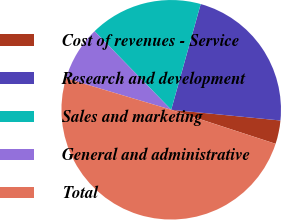<chart> <loc_0><loc_0><loc_500><loc_500><pie_chart><fcel>Cost of revenues - Service<fcel>Research and development<fcel>Sales and marketing<fcel>General and administrative<fcel>Total<nl><fcel>3.46%<fcel>22.23%<fcel>16.63%<fcel>8.08%<fcel>49.6%<nl></chart> 